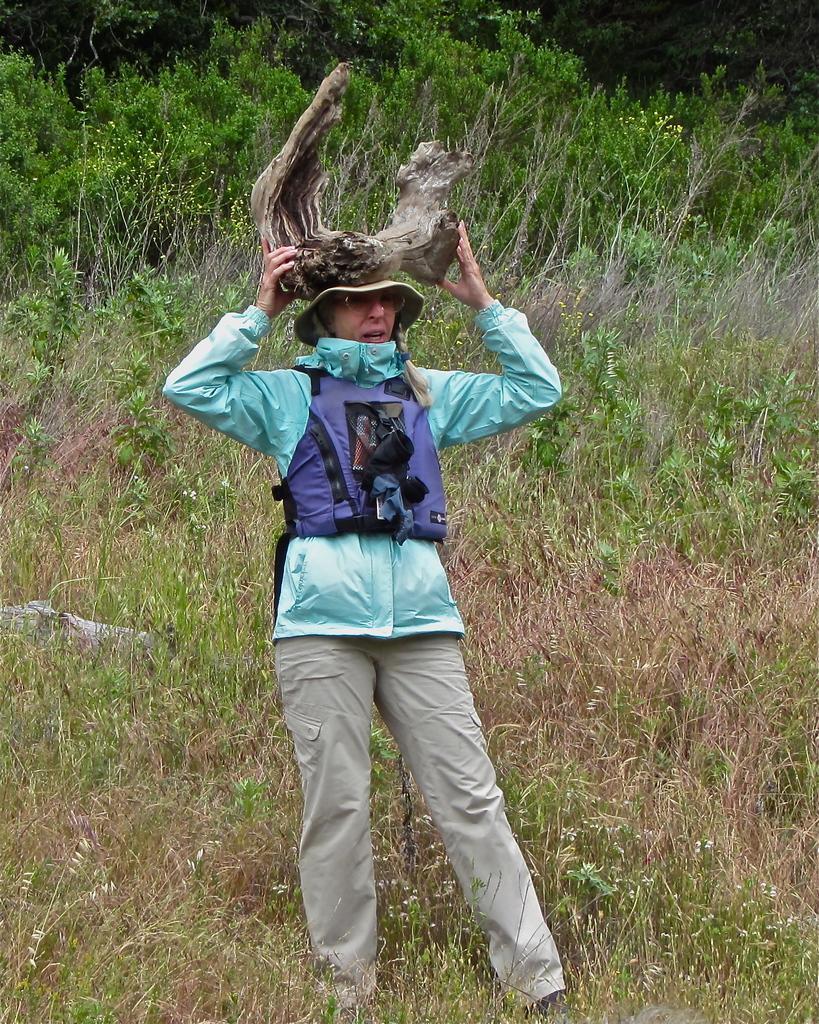How would you summarize this image in a sentence or two? In this image I can see a person standing wearing green, blue and cream color dress and holding some object. Background I can see grass and trees in green color. 